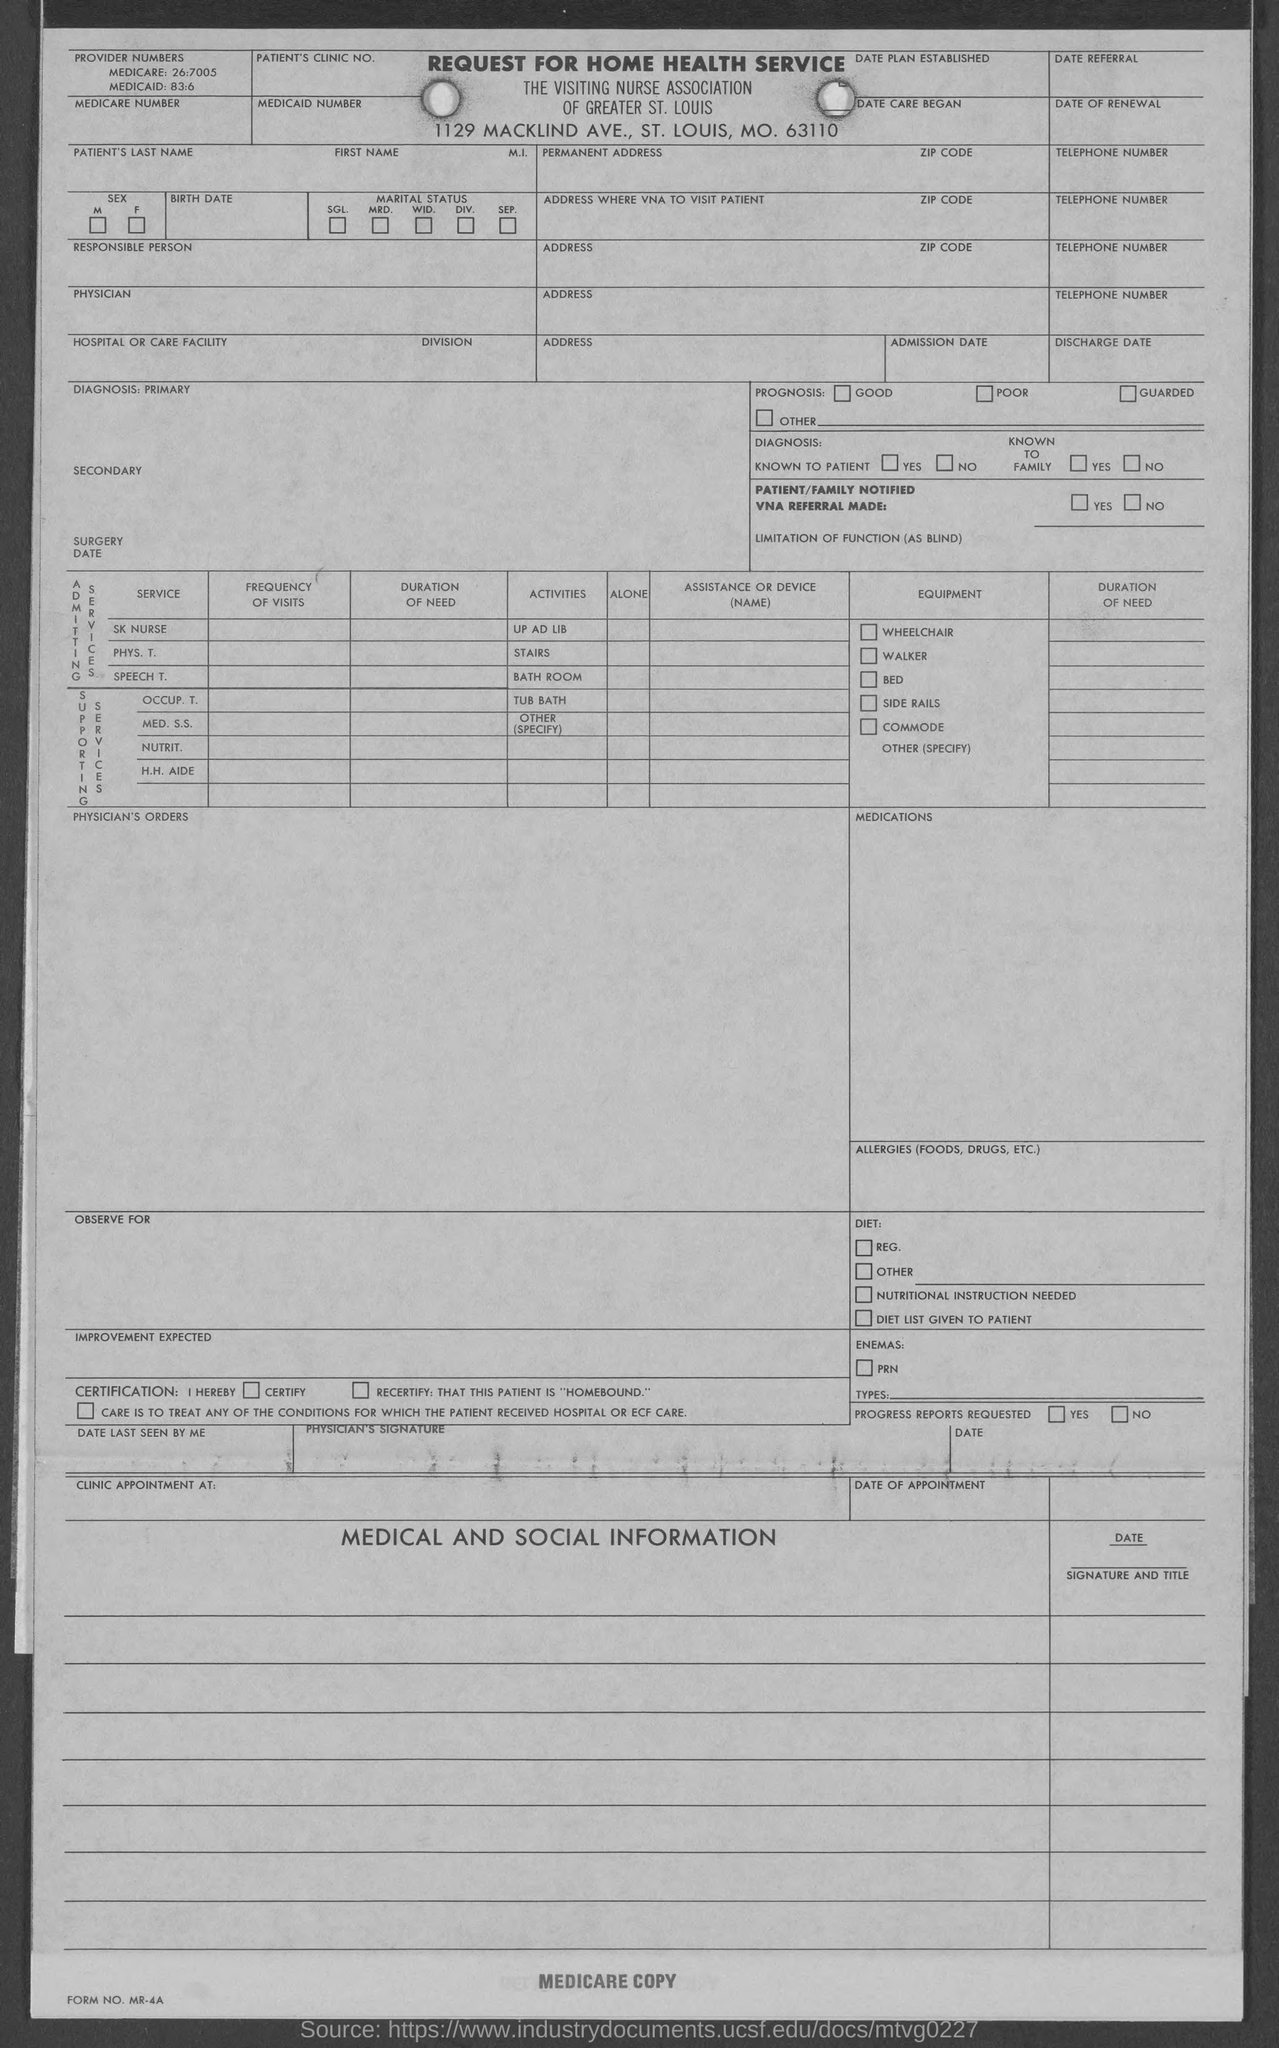What is the Medicare number?
Your answer should be very brief. 26:7005. What is the Medicaid number?
Keep it short and to the point. 83:6. 